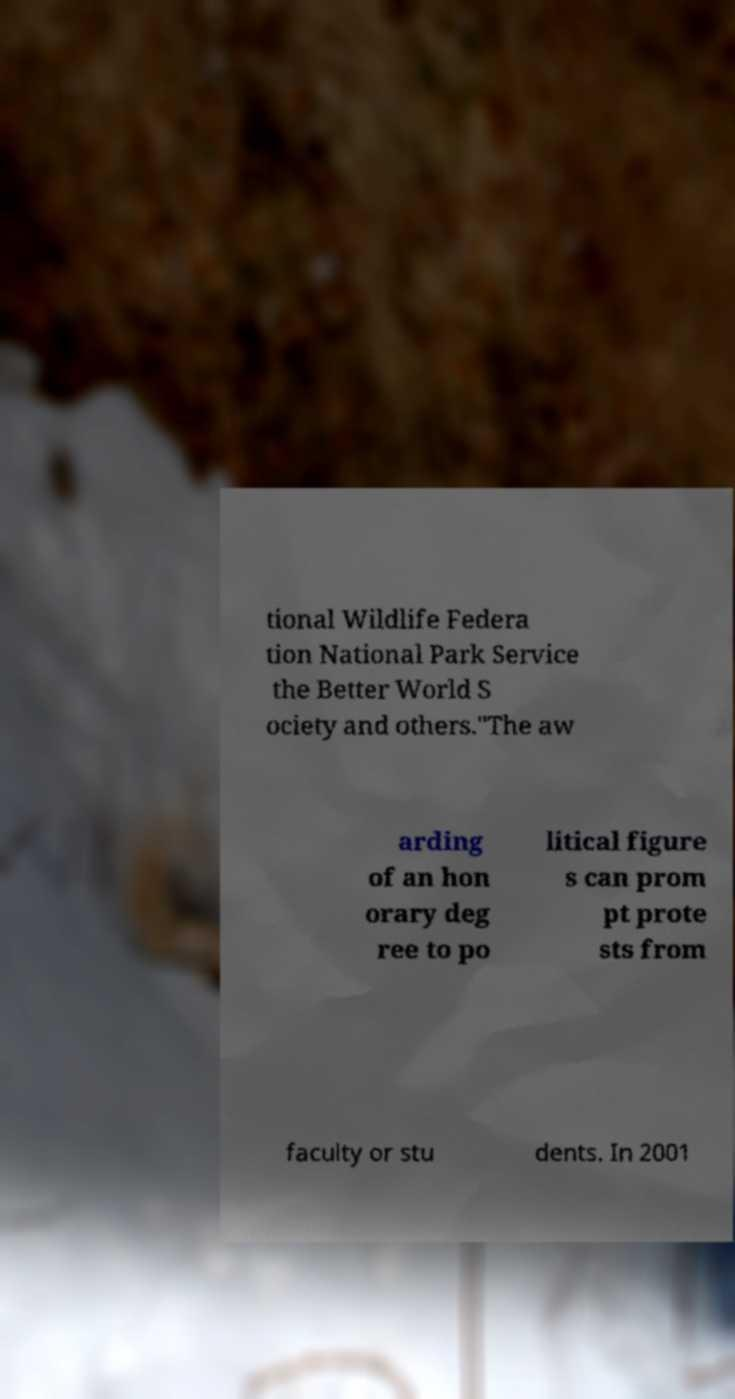Can you accurately transcribe the text from the provided image for me? tional Wildlife Federa tion National Park Service the Better World S ociety and others."The aw arding of an hon orary deg ree to po litical figure s can prom pt prote sts from faculty or stu dents. In 2001 